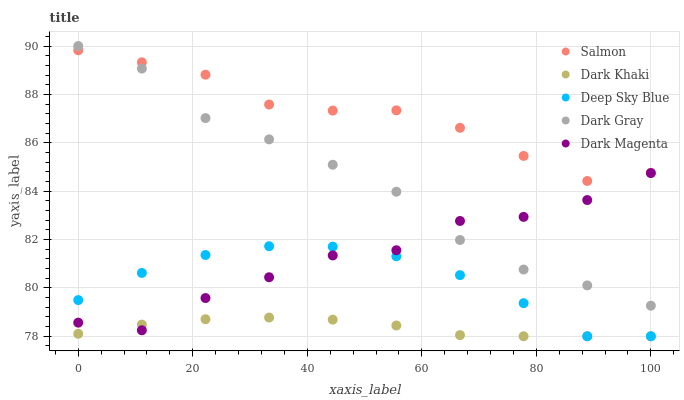Does Dark Khaki have the minimum area under the curve?
Answer yes or no. Yes. Does Salmon have the maximum area under the curve?
Answer yes or no. Yes. Does Dark Gray have the minimum area under the curve?
Answer yes or no. No. Does Dark Gray have the maximum area under the curve?
Answer yes or no. No. Is Dark Khaki the smoothest?
Answer yes or no. Yes. Is Dark Magenta the roughest?
Answer yes or no. Yes. Is Dark Gray the smoothest?
Answer yes or no. No. Is Dark Gray the roughest?
Answer yes or no. No. Does Dark Khaki have the lowest value?
Answer yes or no. Yes. Does Dark Gray have the lowest value?
Answer yes or no. No. Does Dark Gray have the highest value?
Answer yes or no. Yes. Does Salmon have the highest value?
Answer yes or no. No. Is Dark Magenta less than Salmon?
Answer yes or no. Yes. Is Dark Gray greater than Dark Khaki?
Answer yes or no. Yes. Does Dark Magenta intersect Deep Sky Blue?
Answer yes or no. Yes. Is Dark Magenta less than Deep Sky Blue?
Answer yes or no. No. Is Dark Magenta greater than Deep Sky Blue?
Answer yes or no. No. Does Dark Magenta intersect Salmon?
Answer yes or no. No. 